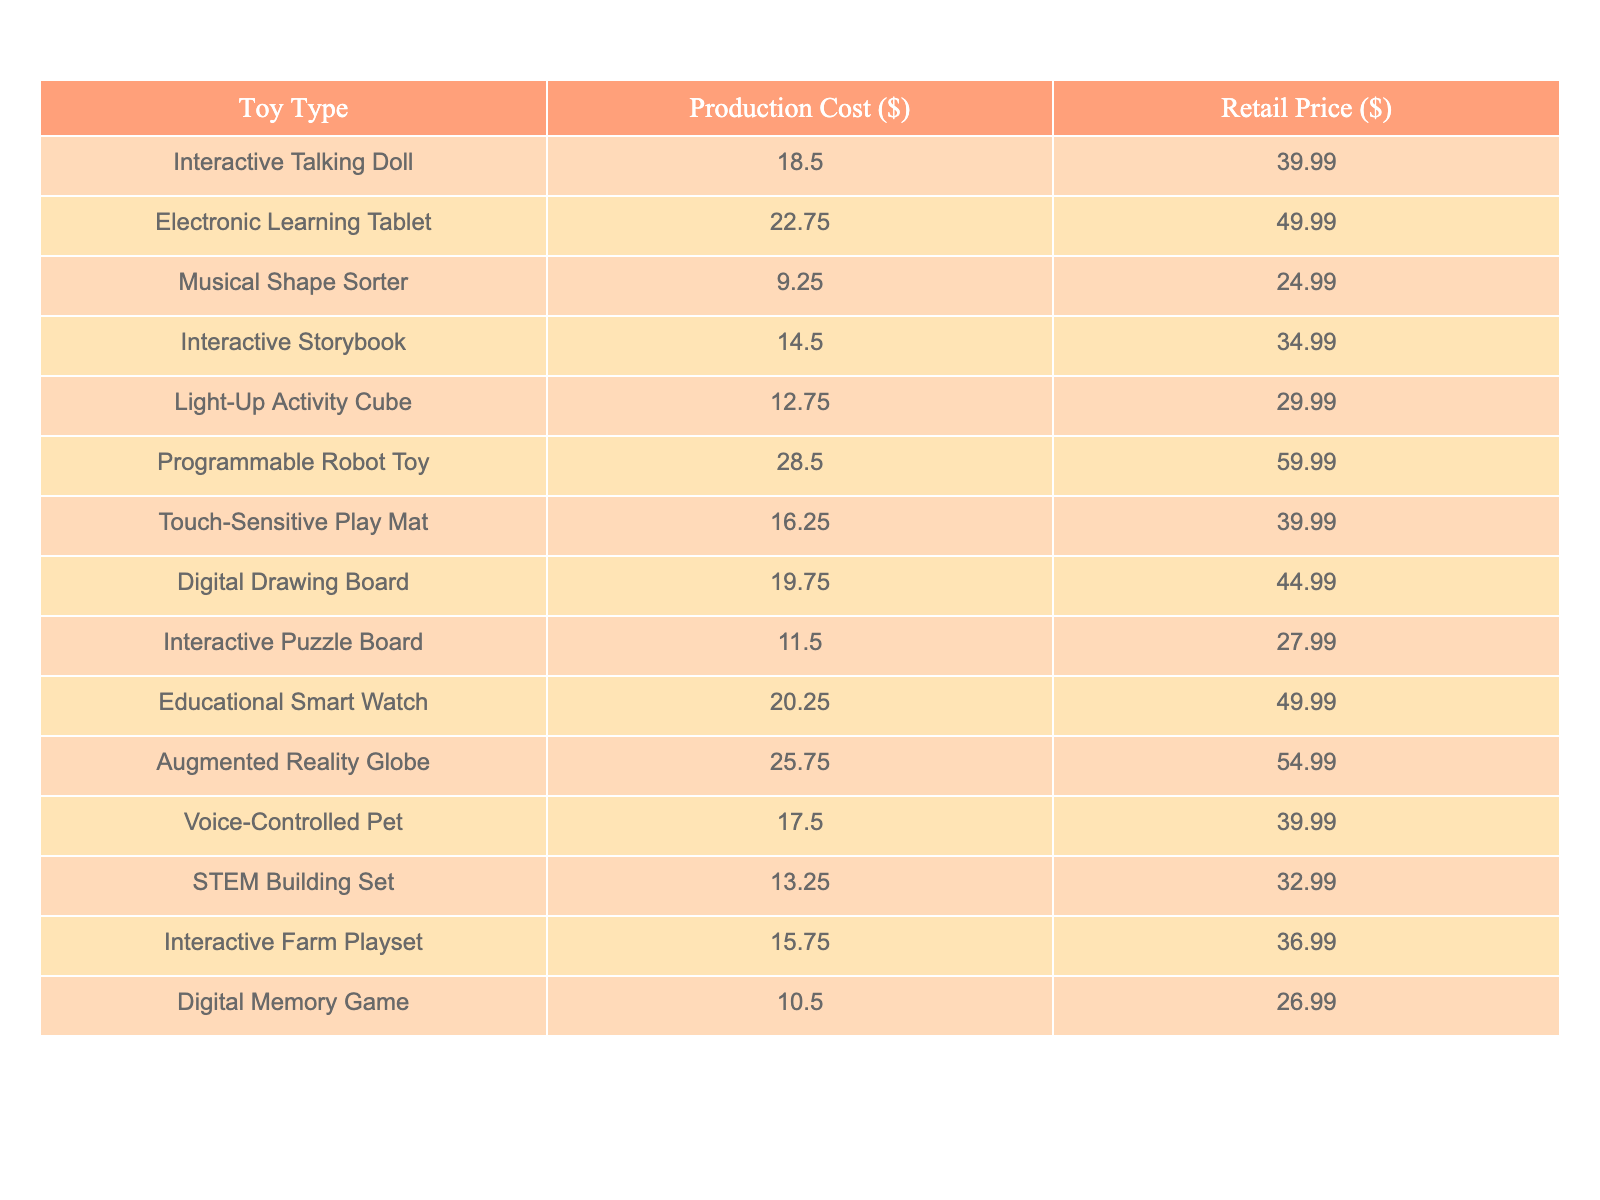What is the production cost of the Programmable Robot Toy? According to the table, the production cost for the Programmable Robot Toy is listed under the "Production Cost" column. The corresponding value is 28.50.
Answer: 28.50 What is the retail price of the Musical Shape Sorter? The table shows the retail price for the Musical Shape Sorter in the "Retail Price" column, which is 24.99.
Answer: 24.99 Which toy type has the highest production cost? To find the highest production cost, we compare all values in the "Production Cost" column. The highest value is 28.50 for the Programmable Robot Toy.
Answer: Programmable Robot Toy What is the average production cost of the toys listed? To find the average production cost, we sum all production costs: (18.50 + 22.75 + 9.25 + 14.50 + 12.75 + 28.50 + 16.25 + 19.75 + 11.50 + 20.25 + 25.75 + 17.50 + 13.25 + 15.75 + 10.50) =  292.75. Then we divide this sum by the number of toys, which is 15, to get an average of 292.75 / 15 = 19.18.
Answer: 19.18 Is the retail price of the Interactive Storybook higher than $30? The retail price for the Interactive Storybook is 34.99, which is indeed greater than $30.
Answer: Yes What is the difference between the production cost and retail price of the Digital Memory Game? The production cost of the Digital Memory Game is 10.50, and the retail price is 26.99. Subtracting the production cost from the retail price gives us: 26.99 - 10.50 = 16.49.
Answer: 16.49 Which toy type has the longest price gap between retail price and production cost? First, we calculate the price gap for each toy by subtracting the production cost from the retail price. The largest gap is for the Programmable Robot Toy with a retail price of 59.99 and a production cost of 28.50, resulting in a gap of 31.49.
Answer: Programmable Robot Toy What percentage of the retail price does the production cost of the Touch-Sensitive Play Mat represent? The production cost for the Touch-Sensitive Play Mat is 16.25, and the retail price is 39.99. To find the percentage, we divide the production cost by the retail price and multiply by 100: (16.25 / 39.99) * 100 = 40.63%.
Answer: 40.63% How many toys have a retail price of $40 or more? Looking at the "Retail Price" column, the toys priced at or above $40 are the Electronic Learning Tablet, Educational Smart Watch, Augmented Reality Globe, and Programmable Robot Toy. There are a total of 4 such toys.
Answer: 4 Is the retail price of the Voice-Controlled Pet less than twice its production cost? The production cost of the Voice-Controlled Pet is 17.50, and twice this amount is 35.00. The retail price is 39.99, which exceeds 35.00. Therefore, the retail price is not less than twice the production cost.
Answer: No 